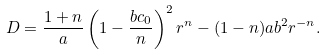<formula> <loc_0><loc_0><loc_500><loc_500>D = \frac { 1 + n } { a } \left ( 1 - \frac { b c _ { 0 } } { n } \right ) ^ { 2 } r ^ { n } - ( 1 - n ) a b ^ { 2 } r ^ { - n } .</formula> 